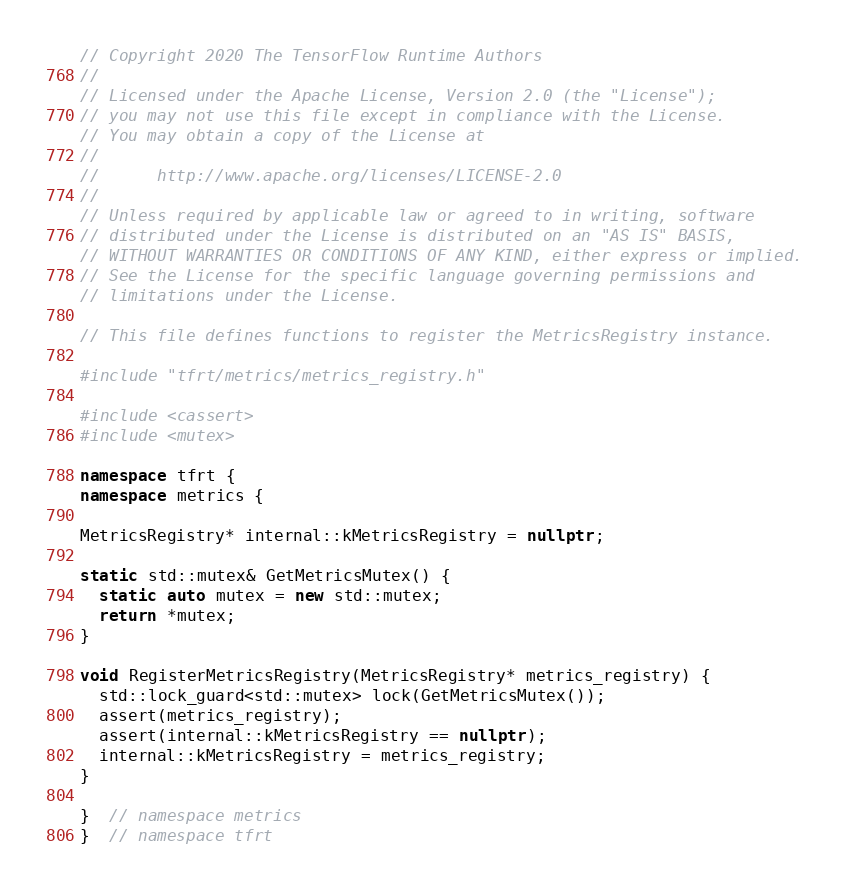<code> <loc_0><loc_0><loc_500><loc_500><_C++_>// Copyright 2020 The TensorFlow Runtime Authors
//
// Licensed under the Apache License, Version 2.0 (the "License");
// you may not use this file except in compliance with the License.
// You may obtain a copy of the License at
//
//      http://www.apache.org/licenses/LICENSE-2.0
//
// Unless required by applicable law or agreed to in writing, software
// distributed under the License is distributed on an "AS IS" BASIS,
// WITHOUT WARRANTIES OR CONDITIONS OF ANY KIND, either express or implied.
// See the License for the specific language governing permissions and
// limitations under the License.

// This file defines functions to register the MetricsRegistry instance.

#include "tfrt/metrics/metrics_registry.h"

#include <cassert>
#include <mutex>

namespace tfrt {
namespace metrics {

MetricsRegistry* internal::kMetricsRegistry = nullptr;

static std::mutex& GetMetricsMutex() {
  static auto mutex = new std::mutex;
  return *mutex;
}

void RegisterMetricsRegistry(MetricsRegistry* metrics_registry) {
  std::lock_guard<std::mutex> lock(GetMetricsMutex());
  assert(metrics_registry);
  assert(internal::kMetricsRegistry == nullptr);
  internal::kMetricsRegistry = metrics_registry;
}

}  // namespace metrics
}  // namespace tfrt
</code> 